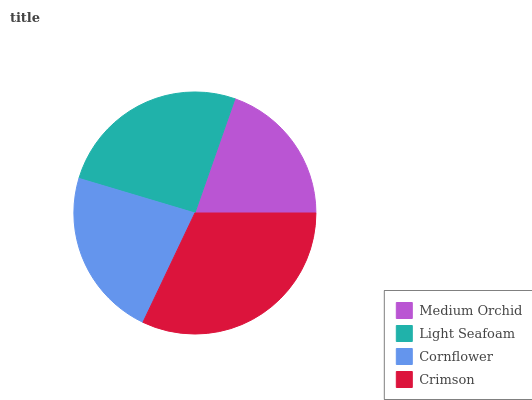Is Medium Orchid the minimum?
Answer yes or no. Yes. Is Crimson the maximum?
Answer yes or no. Yes. Is Light Seafoam the minimum?
Answer yes or no. No. Is Light Seafoam the maximum?
Answer yes or no. No. Is Light Seafoam greater than Medium Orchid?
Answer yes or no. Yes. Is Medium Orchid less than Light Seafoam?
Answer yes or no. Yes. Is Medium Orchid greater than Light Seafoam?
Answer yes or no. No. Is Light Seafoam less than Medium Orchid?
Answer yes or no. No. Is Light Seafoam the high median?
Answer yes or no. Yes. Is Cornflower the low median?
Answer yes or no. Yes. Is Crimson the high median?
Answer yes or no. No. Is Light Seafoam the low median?
Answer yes or no. No. 